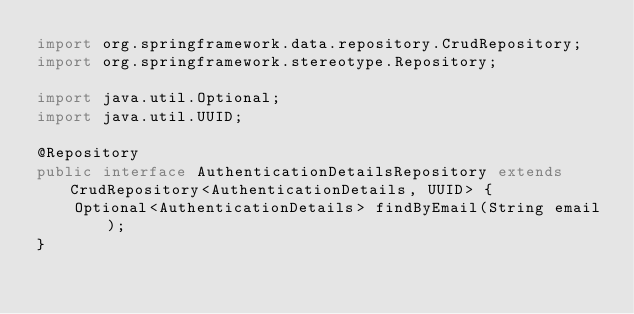<code> <loc_0><loc_0><loc_500><loc_500><_Java_>import org.springframework.data.repository.CrudRepository;
import org.springframework.stereotype.Repository;

import java.util.Optional;
import java.util.UUID;

@Repository
public interface AuthenticationDetailsRepository extends CrudRepository<AuthenticationDetails, UUID> {
    Optional<AuthenticationDetails> findByEmail(String email);
}
</code> 